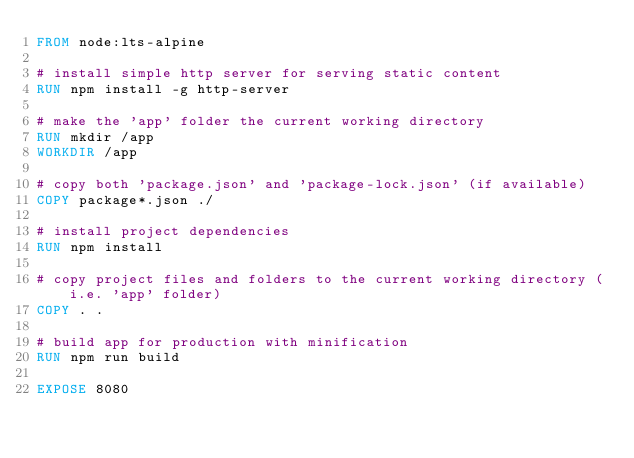Convert code to text. <code><loc_0><loc_0><loc_500><loc_500><_Dockerfile_>FROM node:lts-alpine

# install simple http server for serving static content
RUN npm install -g http-server

# make the 'app' folder the current working directory
RUN mkdir /app
WORKDIR /app

# copy both 'package.json' and 'package-lock.json' (if available)
COPY package*.json ./

# install project dependencies
RUN npm install

# copy project files and folders to the current working directory (i.e. 'app' folder)
COPY . .

# build app for production with minification
RUN npm run build

EXPOSE 8080</code> 